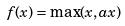<formula> <loc_0><loc_0><loc_500><loc_500>f ( x ) = \max ( x , a x )</formula> 